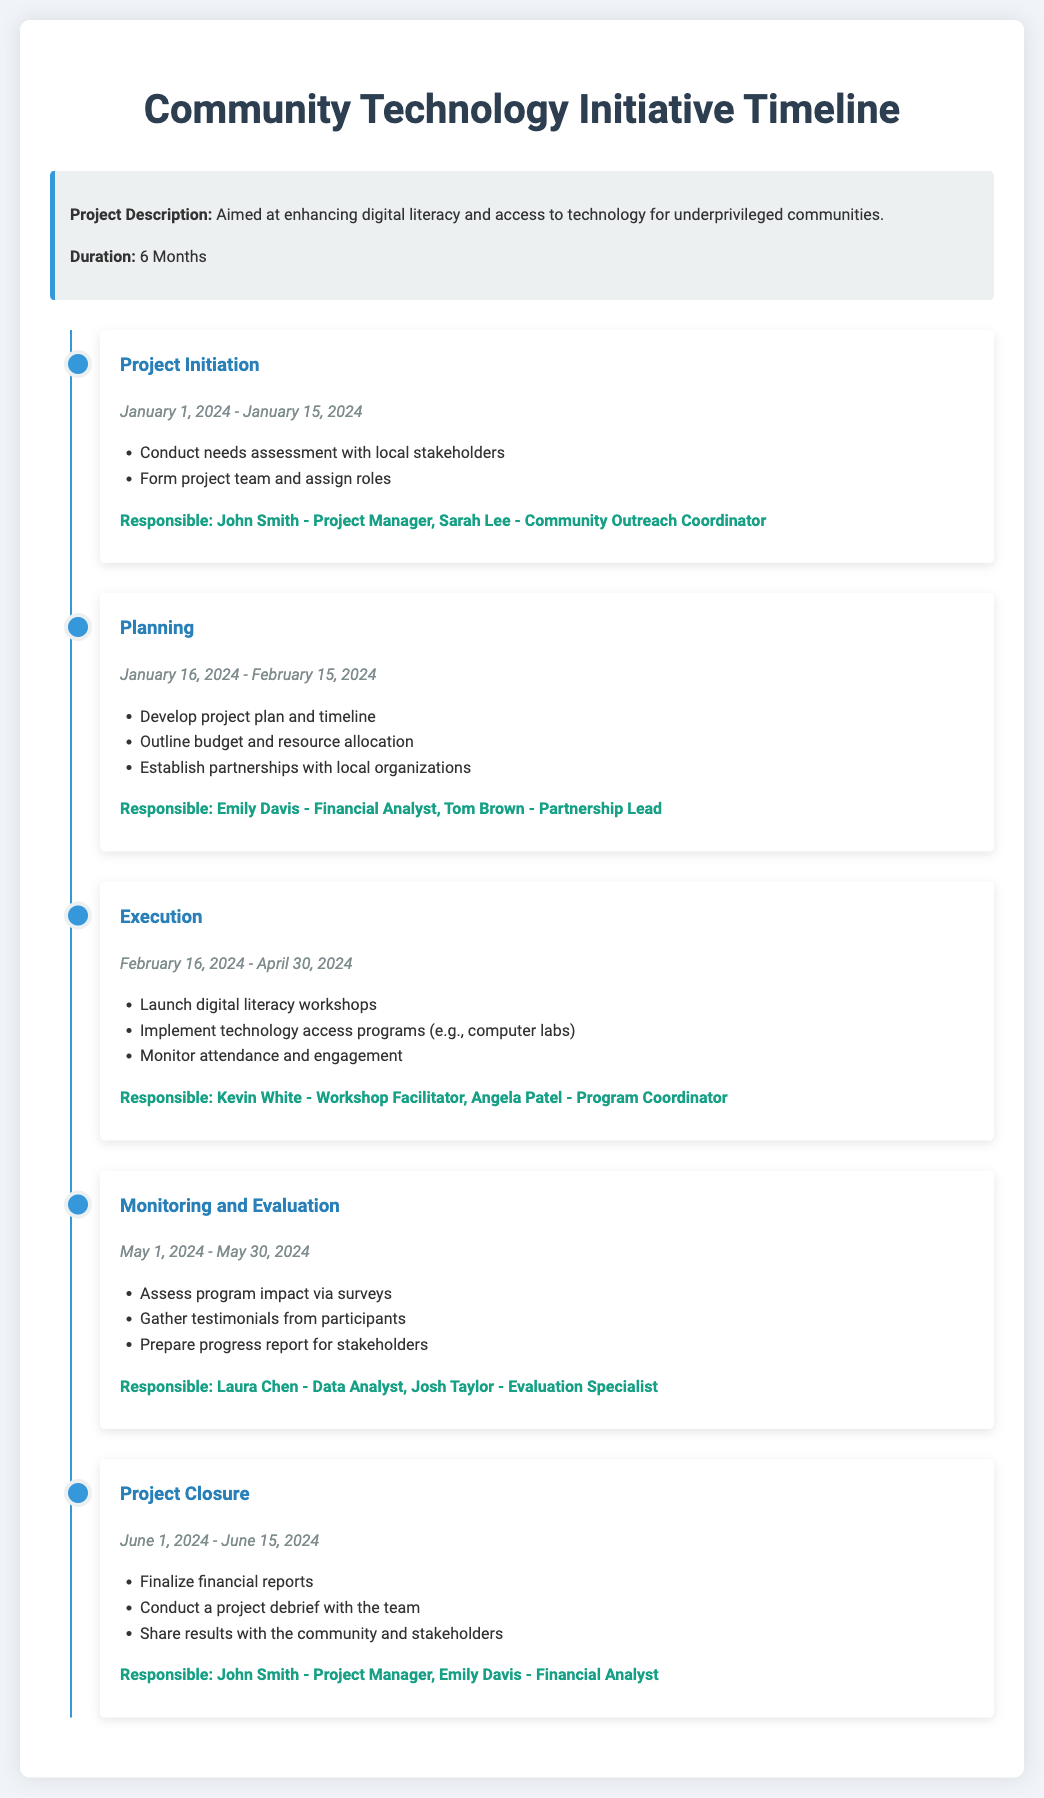What is the project duration? The project duration is explicitly stated in the document as 6 months.
Answer: 6 Months Who is responsible for the project initiation? The document lists John Smith as the Project Manager and Sarah Lee as the Community Outreach Coordinator for the project initiation.
Answer: John Smith, Sarah Lee What is the date range for project execution? The document specifies that the execution phase runs from February 16, 2024, to April 30, 2024.
Answer: February 16, 2024 - April 30, 2024 Which team member is responsible for monitoring and evaluation? Laura Chen is identified as the Data Analyst responsible for monitoring and evaluation in the document.
Answer: Laura Chen What key activity occurs during the planning phase? The document outlines that developing a project plan and timeline is one of the key activities during the planning phase.
Answer: Develop project plan and timeline How many total milestones are listed in the document? The document outlines five key milestones related to the project timeline, from initiation to closure.
Answer: Five What type of program will be launched during execution? The document mentions launching digital literacy workshops as part of the execution phase.
Answer: Digital literacy workshops Who prepares the progress report in the monitoring and evaluation phase? Josh Taylor is listed as the Evaluation Specialist responsible for preparing the progress report in the monitoring and evaluation phase.
Answer: Josh Taylor 